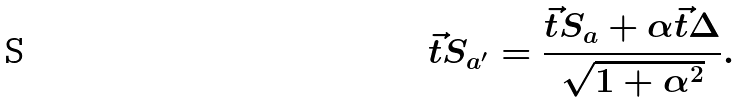<formula> <loc_0><loc_0><loc_500><loc_500>\vec { t } S _ { a ^ { \prime } } = \frac { \vec { t } S _ { a } + \alpha \vec { t } \Delta } { \sqrt { 1 + \alpha ^ { 2 } } } .</formula> 